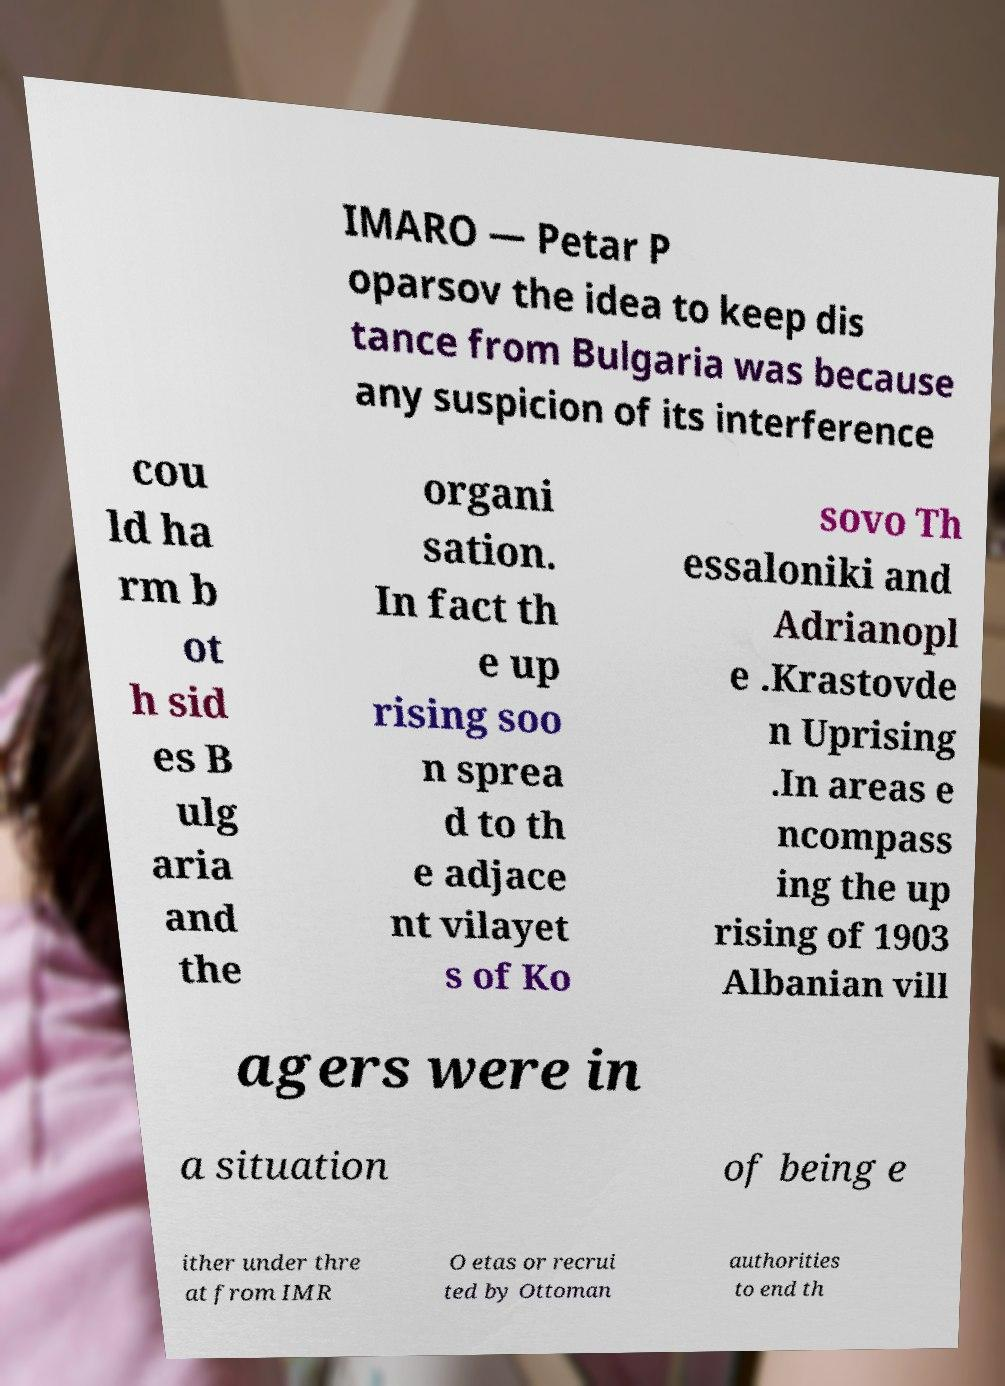There's text embedded in this image that I need extracted. Can you transcribe it verbatim? IMARO — Petar P oparsov the idea to keep dis tance from Bulgaria was because any suspicion of its interference cou ld ha rm b ot h sid es B ulg aria and the organi sation. In fact th e up rising soo n sprea d to th e adjace nt vilayet s of Ko sovo Th essaloniki and Adrianopl e .Krastovde n Uprising .In areas e ncompass ing the up rising of 1903 Albanian vill agers were in a situation of being e ither under thre at from IMR O etas or recrui ted by Ottoman authorities to end th 